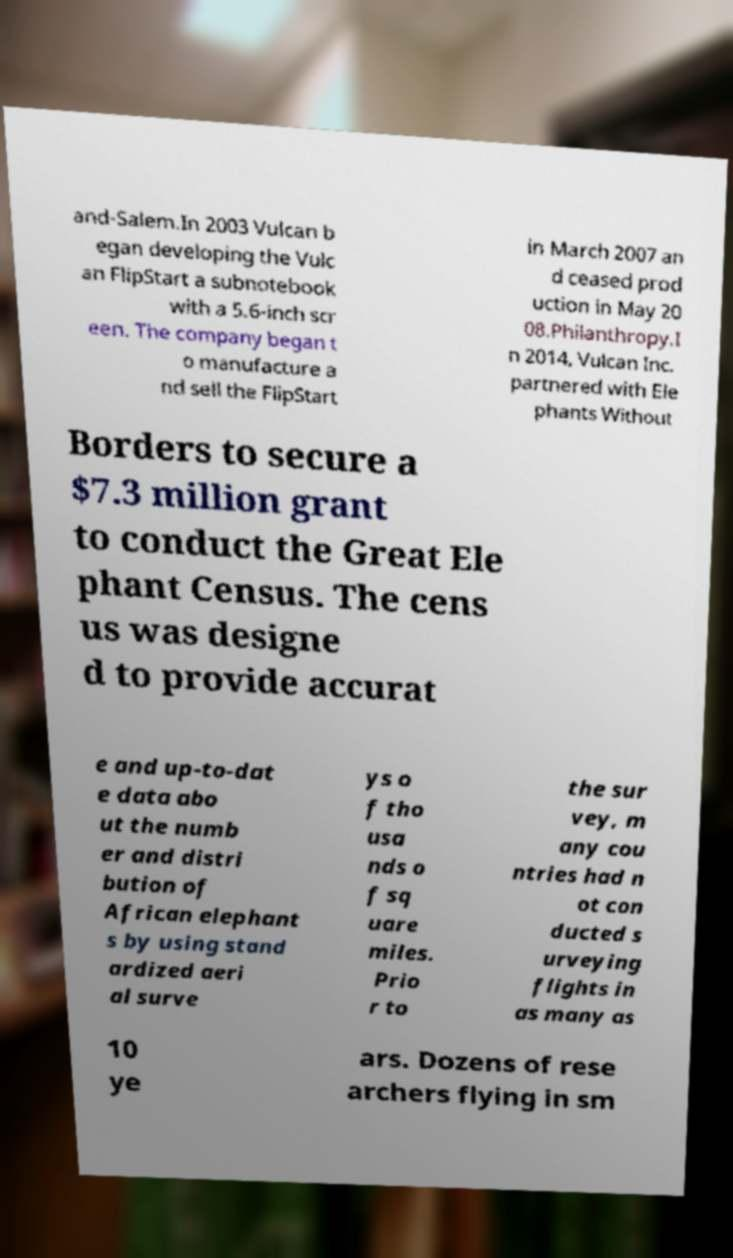Please identify and transcribe the text found in this image. and-Salem.In 2003 Vulcan b egan developing the Vulc an FlipStart a subnotebook with a 5.6-inch scr een. The company began t o manufacture a nd sell the FlipStart in March 2007 an d ceased prod uction in May 20 08.Philanthropy.I n 2014, Vulcan Inc. partnered with Ele phants Without Borders to secure a $7.3 million grant to conduct the Great Ele phant Census. The cens us was designe d to provide accurat e and up-to-dat e data abo ut the numb er and distri bution of African elephant s by using stand ardized aeri al surve ys o f tho usa nds o f sq uare miles. Prio r to the sur vey, m any cou ntries had n ot con ducted s urveying flights in as many as 10 ye ars. Dozens of rese archers flying in sm 